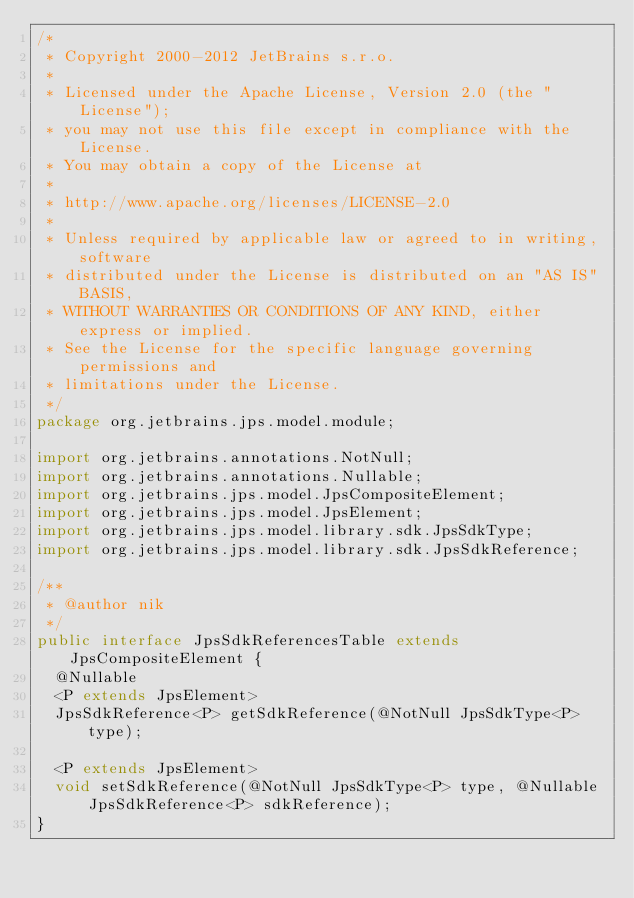Convert code to text. <code><loc_0><loc_0><loc_500><loc_500><_Java_>/*
 * Copyright 2000-2012 JetBrains s.r.o.
 *
 * Licensed under the Apache License, Version 2.0 (the "License");
 * you may not use this file except in compliance with the License.
 * You may obtain a copy of the License at
 *
 * http://www.apache.org/licenses/LICENSE-2.0
 *
 * Unless required by applicable law or agreed to in writing, software
 * distributed under the License is distributed on an "AS IS" BASIS,
 * WITHOUT WARRANTIES OR CONDITIONS OF ANY KIND, either express or implied.
 * See the License for the specific language governing permissions and
 * limitations under the License.
 */
package org.jetbrains.jps.model.module;

import org.jetbrains.annotations.NotNull;
import org.jetbrains.annotations.Nullable;
import org.jetbrains.jps.model.JpsCompositeElement;
import org.jetbrains.jps.model.JpsElement;
import org.jetbrains.jps.model.library.sdk.JpsSdkType;
import org.jetbrains.jps.model.library.sdk.JpsSdkReference;

/**
 * @author nik
 */
public interface JpsSdkReferencesTable extends JpsCompositeElement {
  @Nullable
  <P extends JpsElement>
  JpsSdkReference<P> getSdkReference(@NotNull JpsSdkType<P> type);

  <P extends JpsElement>
  void setSdkReference(@NotNull JpsSdkType<P> type, @Nullable JpsSdkReference<P> sdkReference);
}
</code> 